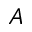Convert formula to latex. <formula><loc_0><loc_0><loc_500><loc_500>A</formula> 